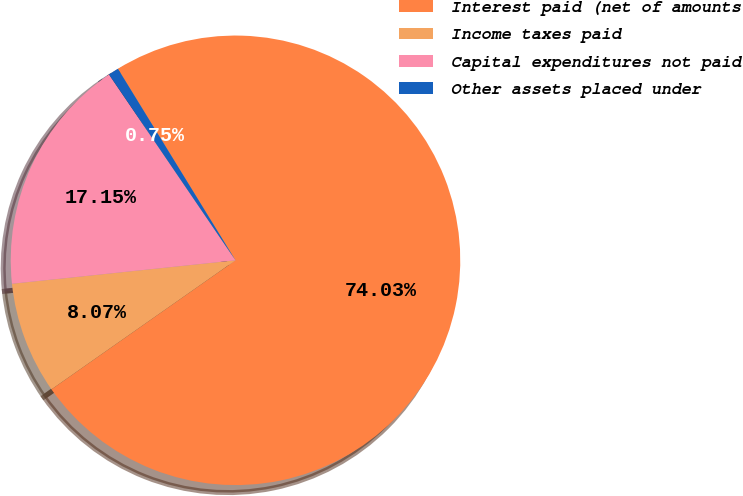Convert chart. <chart><loc_0><loc_0><loc_500><loc_500><pie_chart><fcel>Interest paid (net of amounts<fcel>Income taxes paid<fcel>Capital expenditures not paid<fcel>Other assets placed under<nl><fcel>74.03%<fcel>8.07%<fcel>17.15%<fcel>0.75%<nl></chart> 